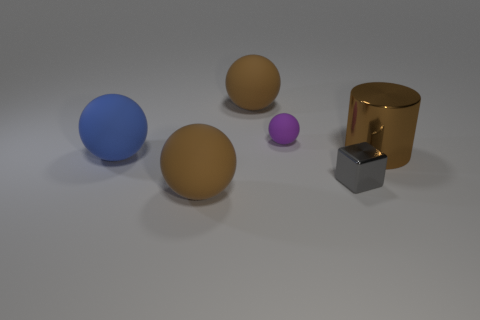Subtract all tiny purple balls. How many balls are left? 3 Subtract all red cylinders. How many brown balls are left? 2 Add 2 small purple rubber balls. How many objects exist? 8 Subtract all purple balls. How many balls are left? 3 Subtract all spheres. How many objects are left? 2 Add 3 small shiny blocks. How many small shiny blocks exist? 4 Subtract 0 purple blocks. How many objects are left? 6 Subtract all yellow blocks. Subtract all yellow spheres. How many blocks are left? 1 Subtract all purple rubber things. Subtract all tiny gray shiny cubes. How many objects are left? 4 Add 5 small gray metallic objects. How many small gray metallic objects are left? 6 